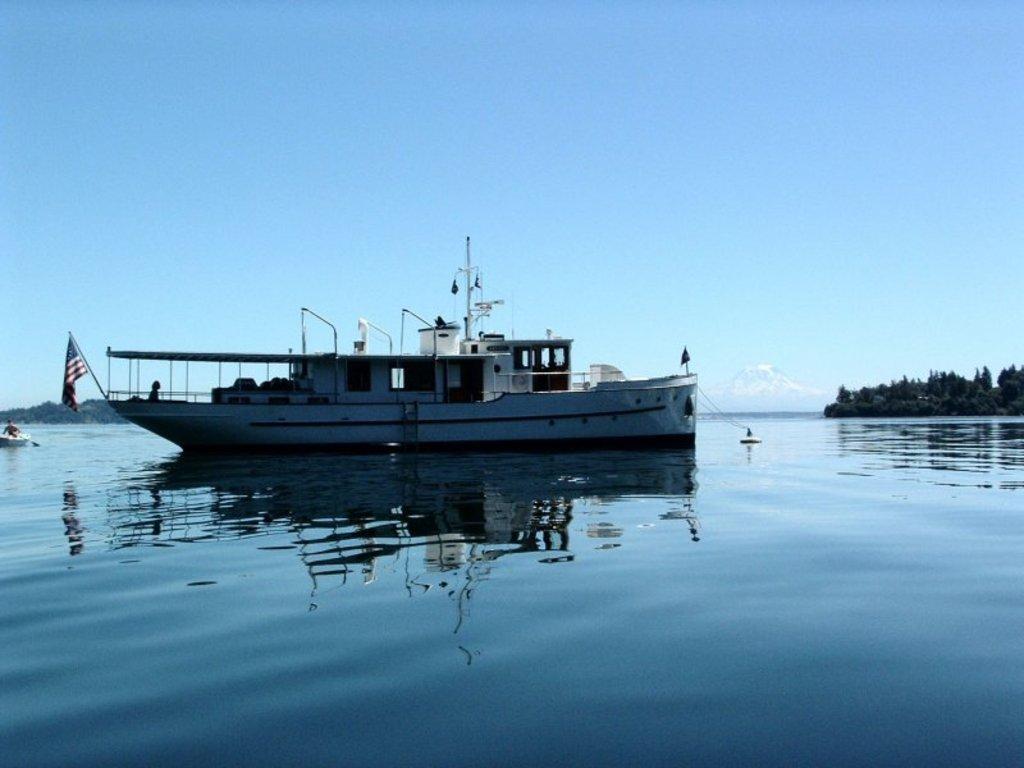Describe this image in one or two sentences. In this image there is a boat sailing on the water, in the background of the image there are trees. 